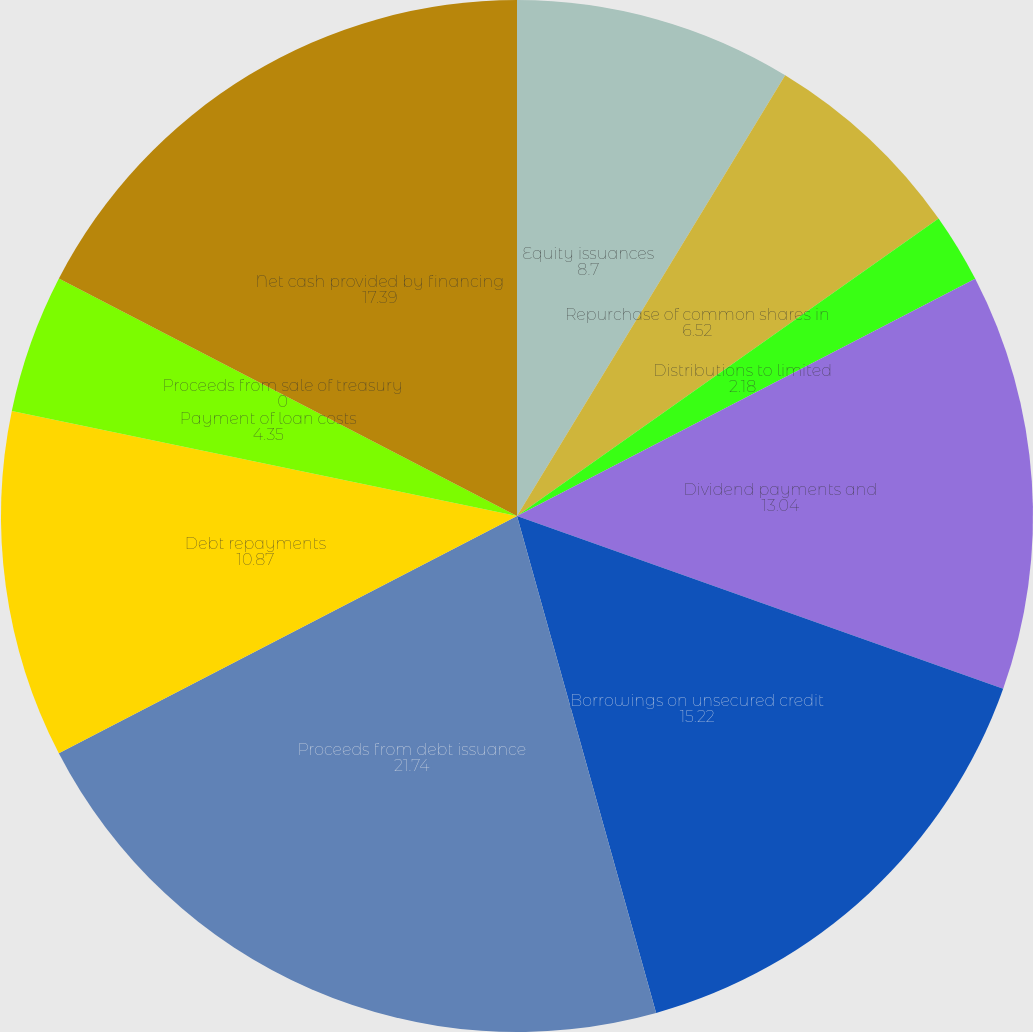Convert chart. <chart><loc_0><loc_0><loc_500><loc_500><pie_chart><fcel>Equity issuances<fcel>Repurchase of common shares in<fcel>Distributions to limited<fcel>Dividend payments and<fcel>Borrowings on unsecured credit<fcel>Proceeds from debt issuance<fcel>Debt repayments<fcel>Payment of loan costs<fcel>Proceeds from sale of treasury<fcel>Net cash provided by financing<nl><fcel>8.7%<fcel>6.52%<fcel>2.18%<fcel>13.04%<fcel>15.22%<fcel>21.74%<fcel>10.87%<fcel>4.35%<fcel>0.0%<fcel>17.39%<nl></chart> 